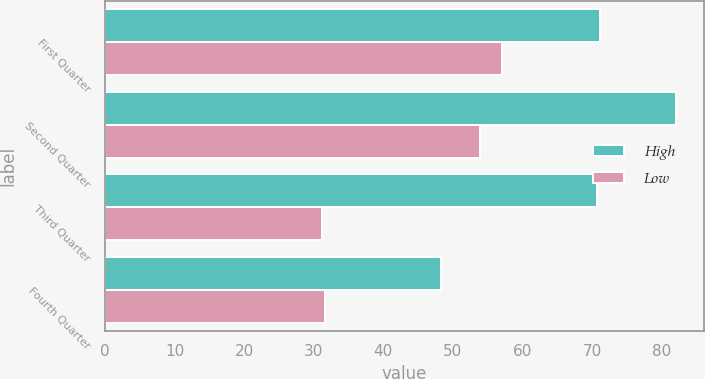Convert chart to OTSL. <chart><loc_0><loc_0><loc_500><loc_500><stacked_bar_chart><ecel><fcel>First Quarter<fcel>Second Quarter<fcel>Third Quarter<fcel>Fourth Quarter<nl><fcel>High<fcel>71.2<fcel>82.02<fcel>70.64<fcel>48.29<nl><fcel>Low<fcel>57.07<fcel>53.86<fcel>31.22<fcel>31.64<nl></chart> 